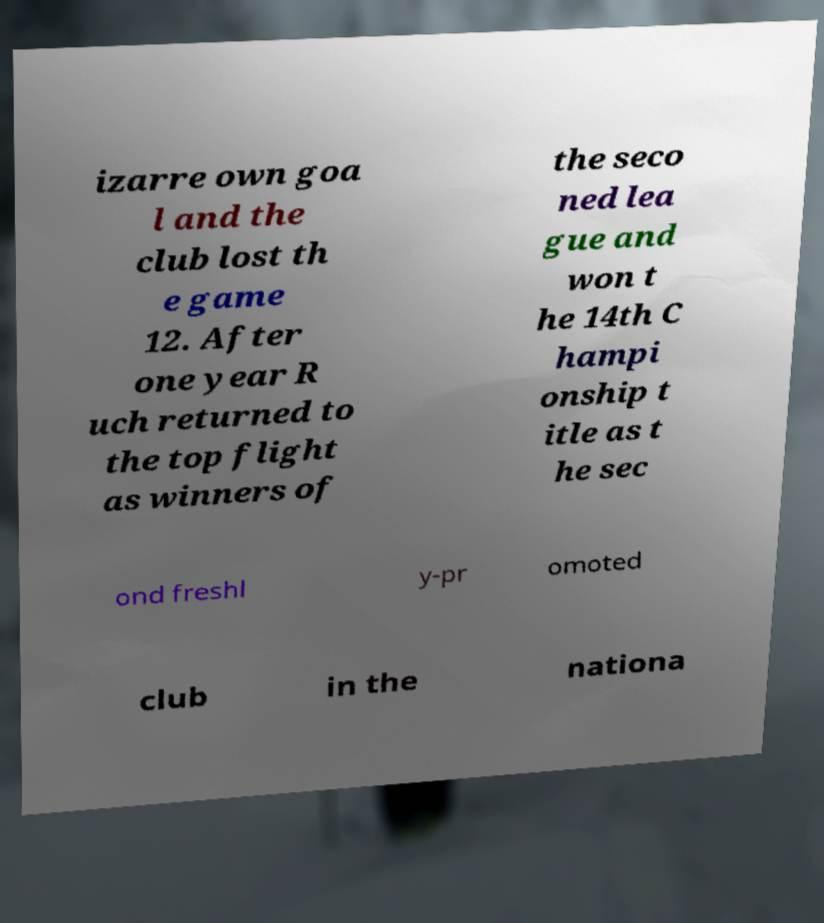For documentation purposes, I need the text within this image transcribed. Could you provide that? izarre own goa l and the club lost th e game 12. After one year R uch returned to the top flight as winners of the seco ned lea gue and won t he 14th C hampi onship t itle as t he sec ond freshl y-pr omoted club in the nationa 